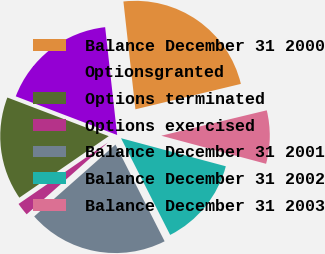Convert chart to OTSL. <chart><loc_0><loc_0><loc_500><loc_500><pie_chart><fcel>Balance December 31 2000<fcel>Optionsgranted<fcel>Options terminated<fcel>Options exercised<fcel>Balance December 31 2001<fcel>Balance December 31 2002<fcel>Balance December 31 2003<nl><fcel>23.0%<fcel>17.44%<fcel>15.39%<fcel>1.93%<fcel>20.96%<fcel>13.35%<fcel>7.93%<nl></chart> 